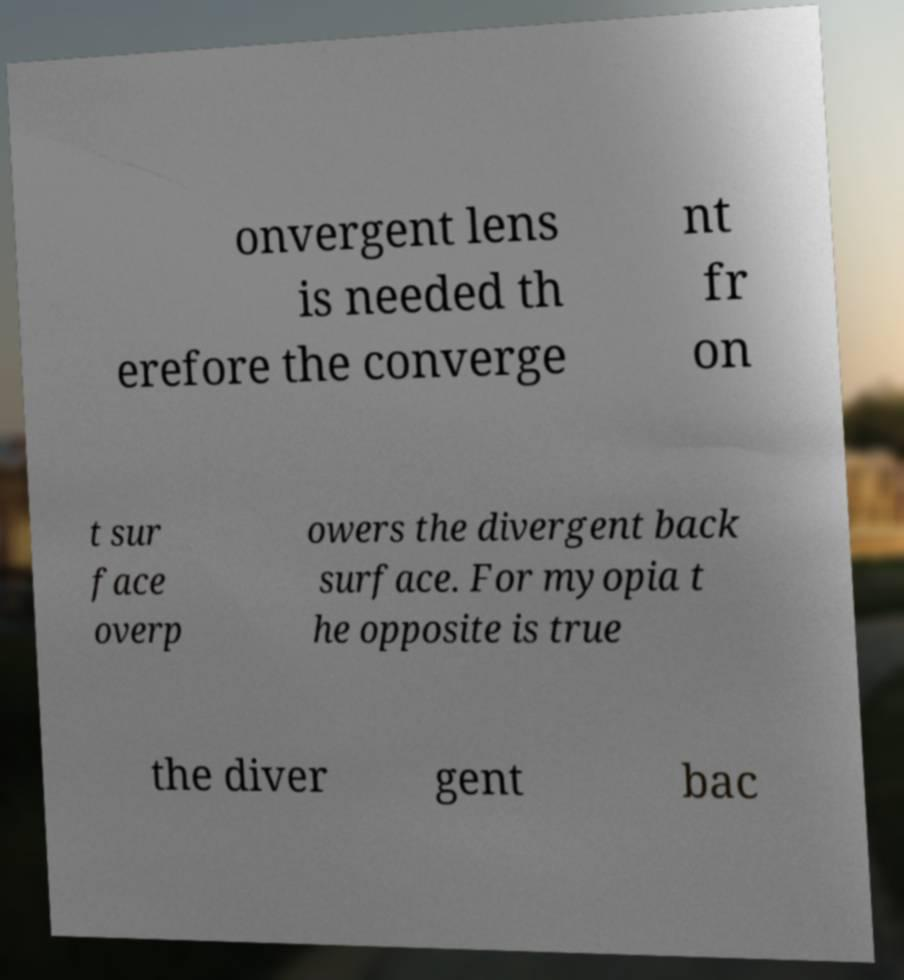Can you read and provide the text displayed in the image?This photo seems to have some interesting text. Can you extract and type it out for me? onvergent lens is needed th erefore the converge nt fr on t sur face overp owers the divergent back surface. For myopia t he opposite is true the diver gent bac 